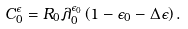Convert formula to latex. <formula><loc_0><loc_0><loc_500><loc_500>C _ { 0 } ^ { \epsilon } = R _ { 0 } \lambda _ { 0 } ^ { \epsilon _ { 0 } } \left ( 1 - \epsilon _ { 0 } - \Delta \epsilon \right ) .</formula> 